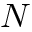<formula> <loc_0><loc_0><loc_500><loc_500>N</formula> 